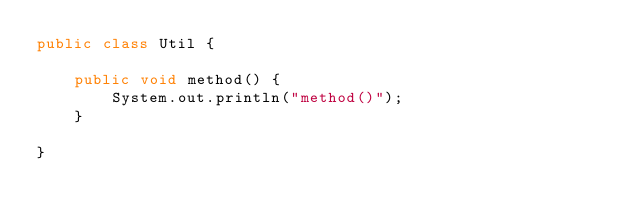<code> <loc_0><loc_0><loc_500><loc_500><_Java_>public class Util {

    public void method() {
        System.out.println("method()");
    }

}
</code> 